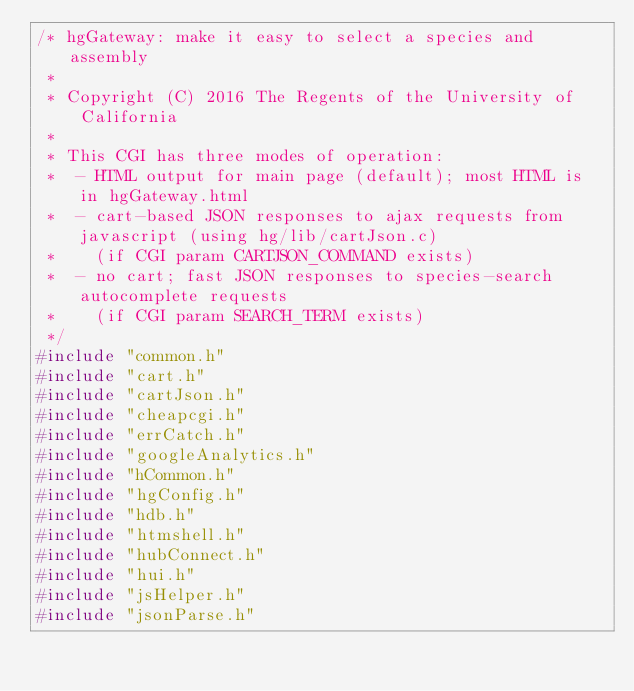<code> <loc_0><loc_0><loc_500><loc_500><_C_>/* hgGateway: make it easy to select a species and assembly
 *
 * Copyright (C) 2016 The Regents of the University of California
 *
 * This CGI has three modes of operation:
 *  - HTML output for main page (default); most HTML is in hgGateway.html
 *  - cart-based JSON responses to ajax requests from javascript (using hg/lib/cartJson.c)
 *    (if CGI param CARTJSON_COMMAND exists)
 *  - no cart; fast JSON responses to species-search autocomplete requests
 *    (if CGI param SEARCH_TERM exists)
 */
#include "common.h"
#include "cart.h"
#include "cartJson.h"
#include "cheapcgi.h"
#include "errCatch.h"
#include "googleAnalytics.h"
#include "hCommon.h"
#include "hgConfig.h"
#include "hdb.h"
#include "htmshell.h"
#include "hubConnect.h"
#include "hui.h"
#include "jsHelper.h"
#include "jsonParse.h"</code> 